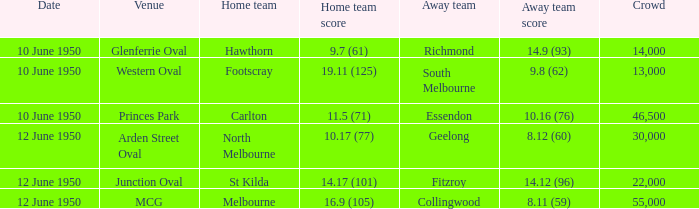Who was the away team when the VFL played at MCG? Collingwood. Write the full table. {'header': ['Date', 'Venue', 'Home team', 'Home team score', 'Away team', 'Away team score', 'Crowd'], 'rows': [['10 June 1950', 'Glenferrie Oval', 'Hawthorn', '9.7 (61)', 'Richmond', '14.9 (93)', '14,000'], ['10 June 1950', 'Western Oval', 'Footscray', '19.11 (125)', 'South Melbourne', '9.8 (62)', '13,000'], ['10 June 1950', 'Princes Park', 'Carlton', '11.5 (71)', 'Essendon', '10.16 (76)', '46,500'], ['12 June 1950', 'Arden Street Oval', 'North Melbourne', '10.17 (77)', 'Geelong', '8.12 (60)', '30,000'], ['12 June 1950', 'Junction Oval', 'St Kilda', '14.17 (101)', 'Fitzroy', '14.12 (96)', '22,000'], ['12 June 1950', 'MCG', 'Melbourne', '16.9 (105)', 'Collingwood', '8.11 (59)', '55,000']]} 